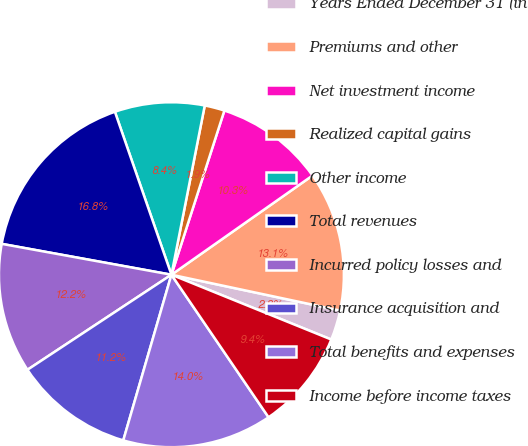Convert chart to OTSL. <chart><loc_0><loc_0><loc_500><loc_500><pie_chart><fcel>Years Ended December 31 (in<fcel>Premiums and other<fcel>Net investment income<fcel>Realized capital gains<fcel>Other income<fcel>Total revenues<fcel>Incurred policy losses and<fcel>Insurance acquisition and<fcel>Total benefits and expenses<fcel>Income before income taxes<nl><fcel>2.8%<fcel>13.08%<fcel>10.28%<fcel>1.87%<fcel>8.41%<fcel>16.82%<fcel>12.15%<fcel>11.21%<fcel>14.02%<fcel>9.35%<nl></chart> 